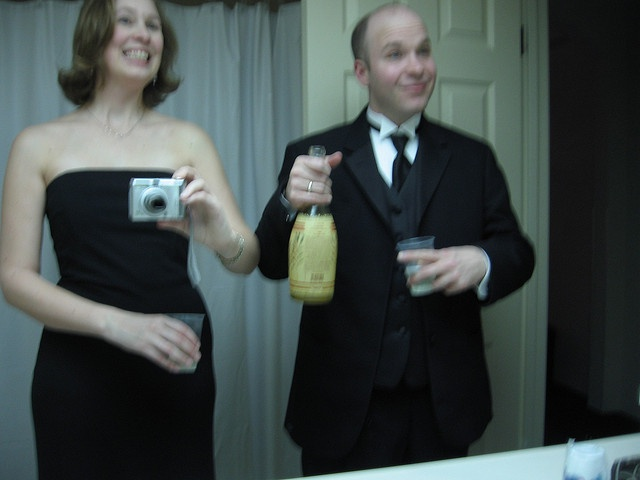Describe the objects in this image and their specific colors. I can see people in black, darkgray, gray, and lightgray tones, people in black, darkgray, gray, and olive tones, bottle in black, olive, darkgray, and lightgreen tones, cup in black, gray, darkgray, and blue tones, and tie in black, blue, navy, and gray tones in this image. 